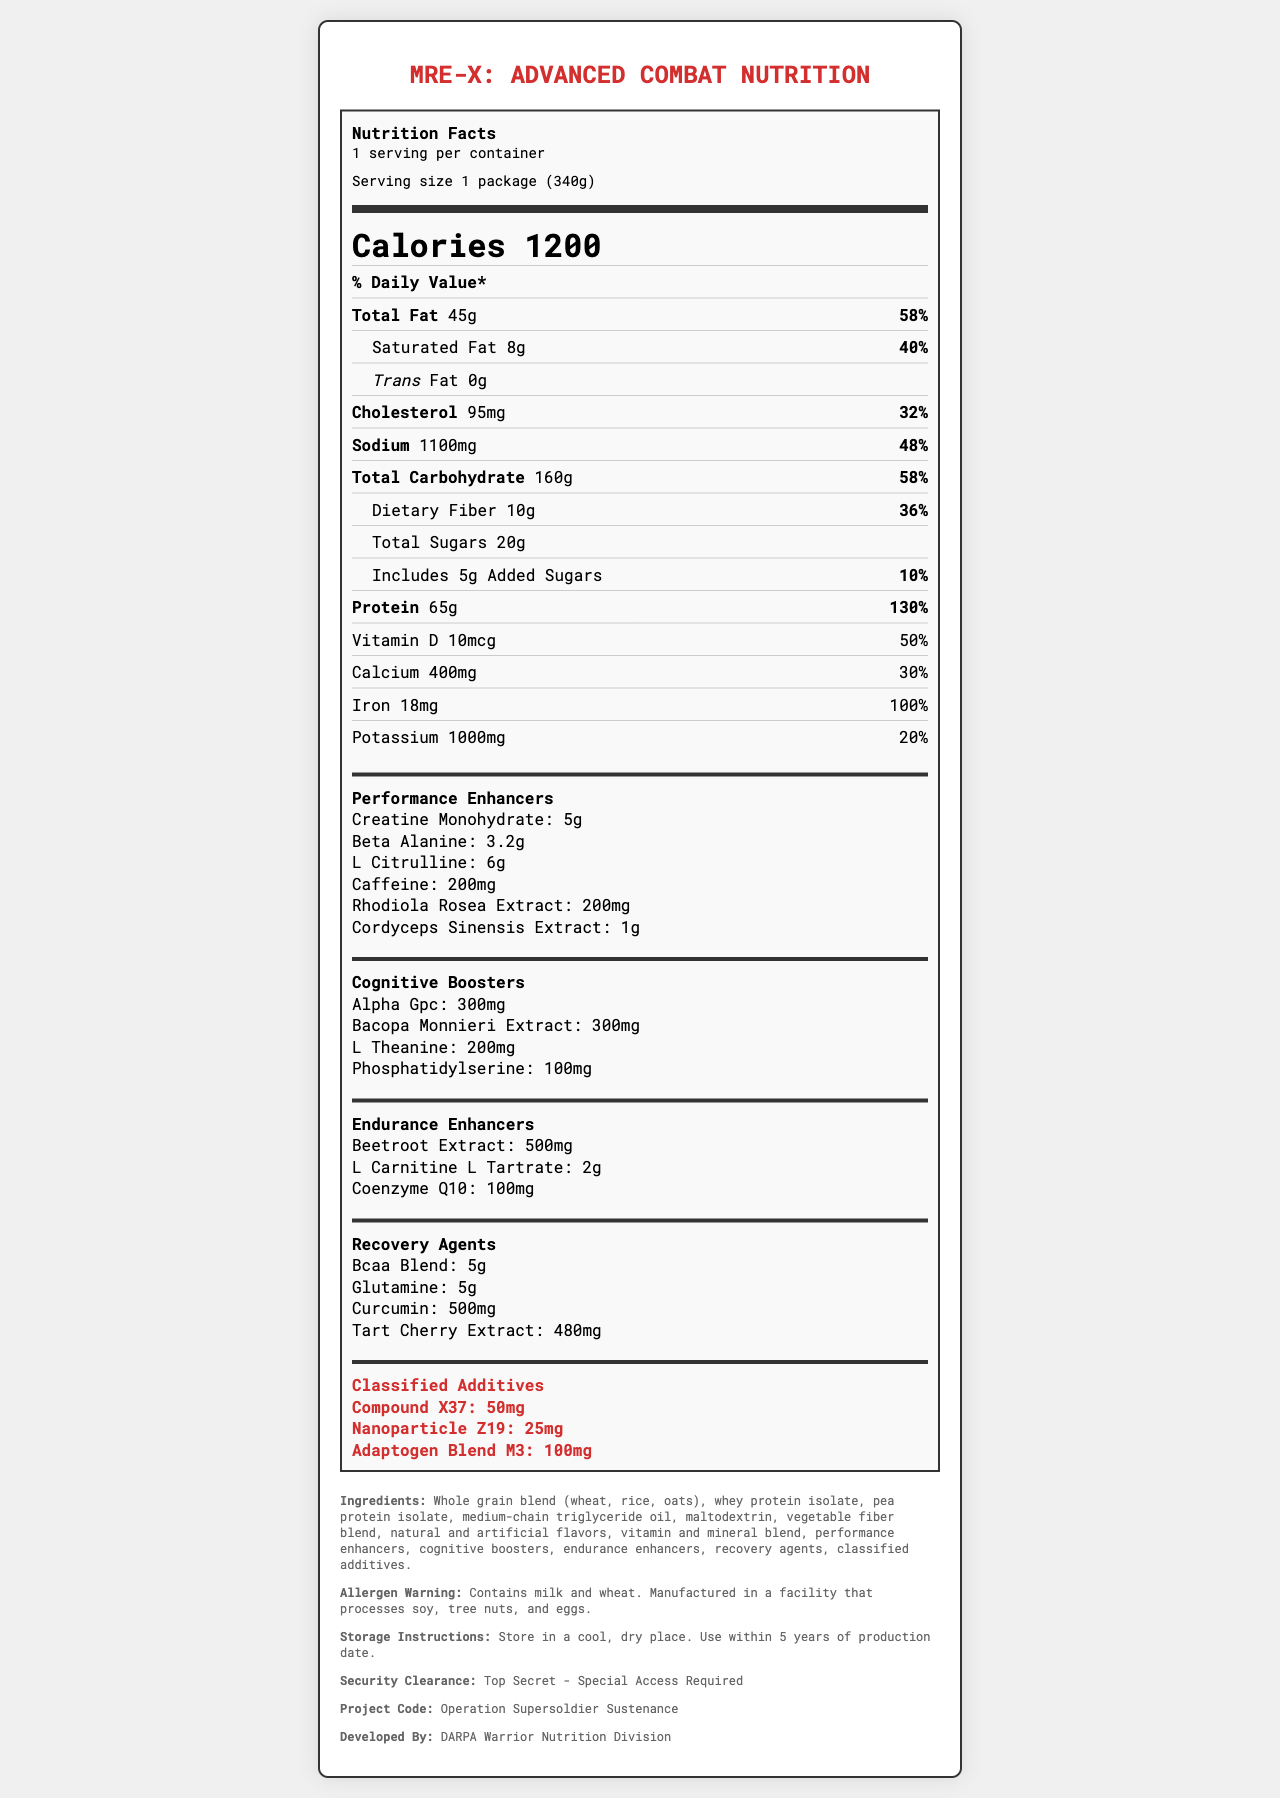what is the serving size for MRE-X: Advanced Combat Nutrition? The serving size is stated as "1 package (340g)" in the document.
Answer: 1 package (340g) how many calories does one serving of MRE-X contain? The document mentions that each serving contains 1200 calories.
Answer: 1200 what percentage of the daily value is the total fat content? The total fat content is listed as 45g, which is noted to be 58% of the daily value.
Answer: 58% how much potassium is included in one serving? The label specifies that one serving contains 1000mg of potassium, which is 20% of the daily value.
Answer: 1000mg what is the daily value percentage for iron? The iron content is 18mg, and it meets 100% of the daily value per serving.
Answer: 100% what are the specific performance enhancers included in MRE-X? The document lists these substances as performance enhancers, with their respective amounts.
Answer: creatine monohydrate, beta-alanine, l-citrulline, caffeine, rhodiola rosea extract, cordyceps sinensis extract which of the following ingredients is not listed under the cognitive boosters category? A. Alpha GPC B. Bacopa Monnieri Extract C. L-Carnitine L-Tartrate D. L-Theanine L-Carnitine L-Tartrate is listed under endurance enhancers, not cognitive boosters.
Answer: C what is the serving size of dietary fiber? A. 5g B. 10g C. 20g D. 15g The document states that the dietary fiber content is 10g per serving.
Answer: B is there any trans fat in MRE-X: Advanced Combat Nutrition? The document clearly mentions that the trans fat content is 0g.
Answer: No summarize the main components of the document. The document provides comprehensive information on the nutrition facts and special components used in MRE-X, intended for military personnel to enhance performance and recovery.
Answer: The document describes the nutritional content of MRE-X: Advanced Combat Nutrition, detailing the macronutrients, micronutrients, performance enhancers, cognitive boosters, endurance enhancers, recovery agents, and classified additives. It also includes information on ingredients, allergen warnings, storage instructions, security clearance, project code, and the developing agency. what are the exact values for the classified additives? The document lists these quantities under the section for classified additives.
Answer: Compound X37: 50mg, Nanoparticle Z19: 25mg, Adaptogen Blend M3: 100mg what is the project code for MRE-X? The document mentions that the project code is "Operation Supersoldier Sustenance."
Answer: Operation Supersoldier Sustenance what flavor varieties does MRE-X come in? The document does not provide any information about flavor varieties.
Answer: Cannot be determined 